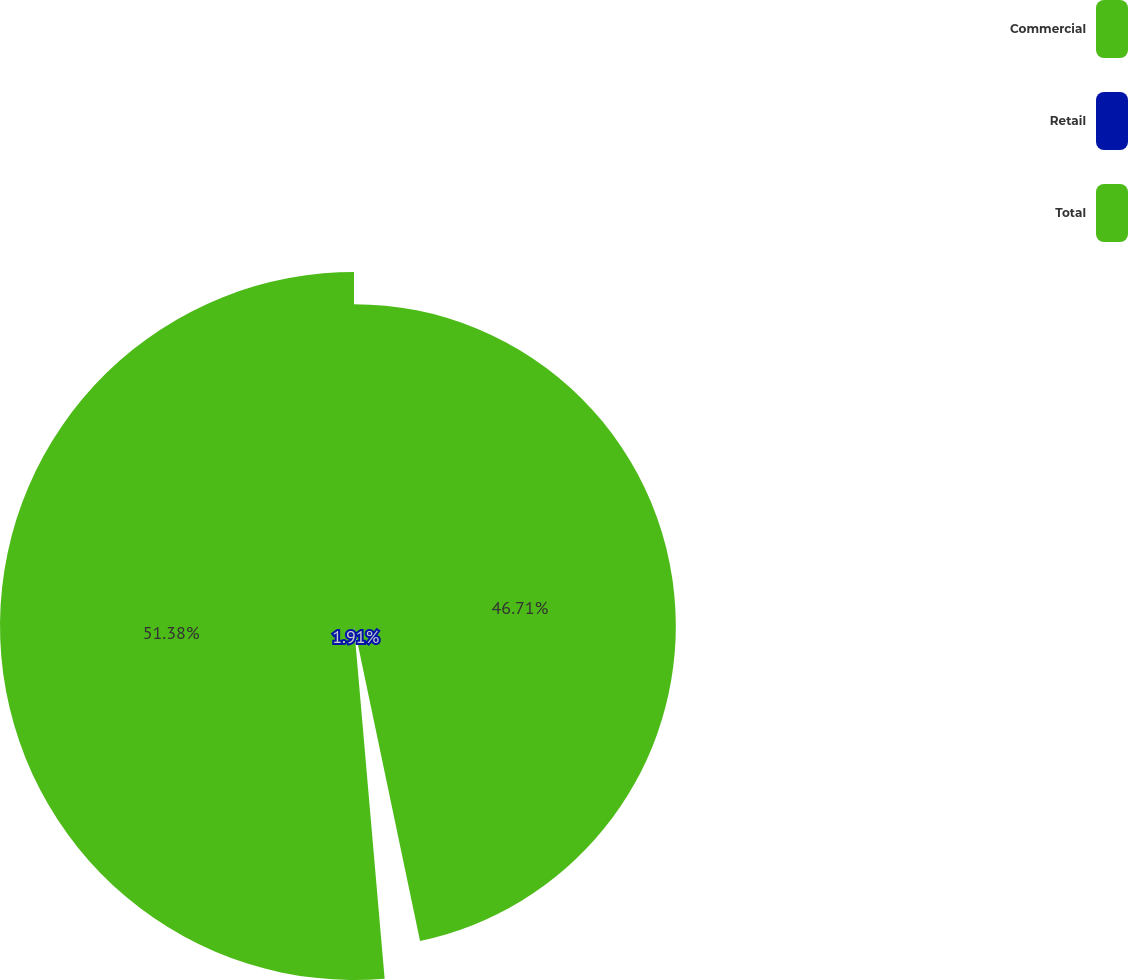<chart> <loc_0><loc_0><loc_500><loc_500><pie_chart><fcel>Commercial<fcel>Retail<fcel>Total<nl><fcel>46.71%<fcel>1.91%<fcel>51.38%<nl></chart> 